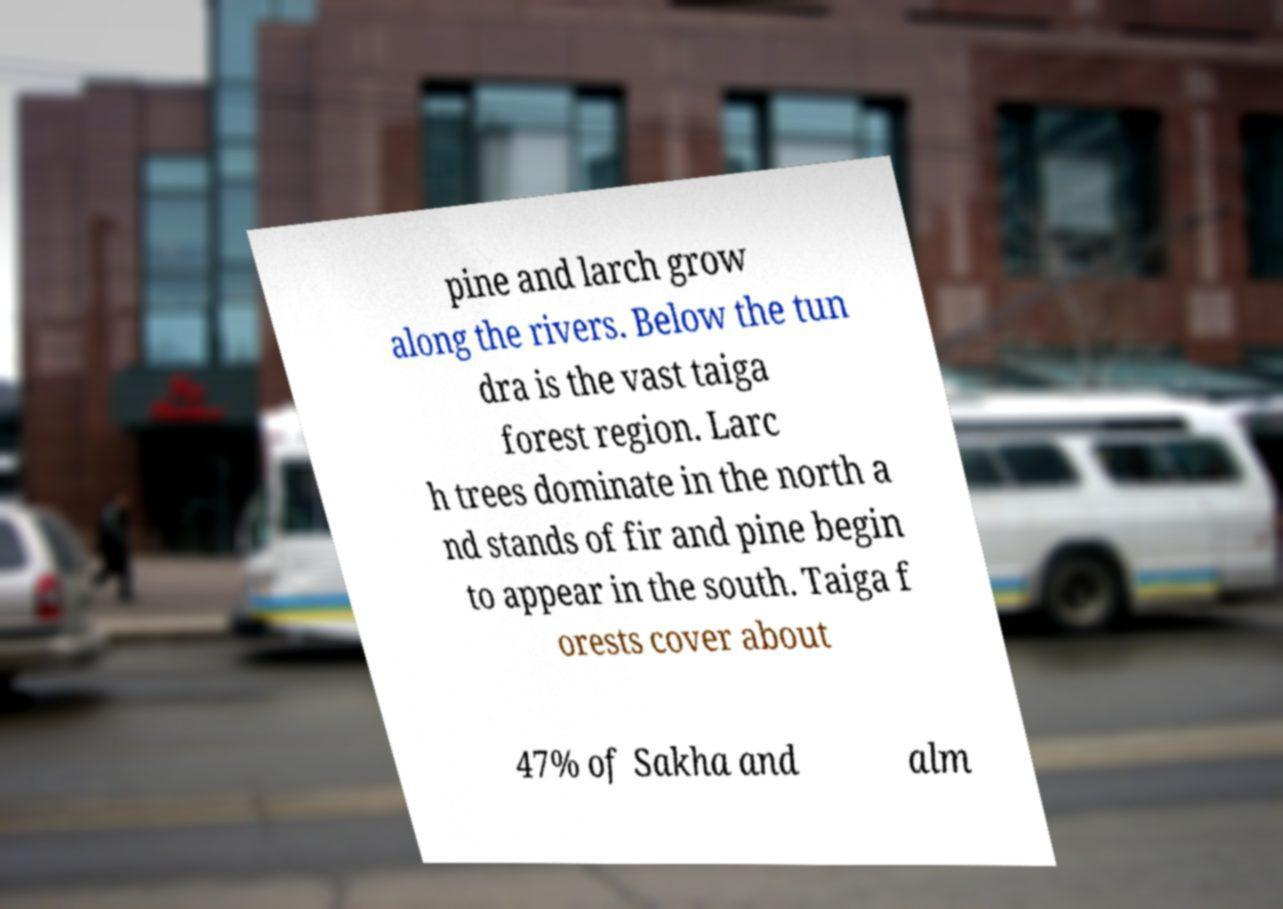What messages or text are displayed in this image? I need them in a readable, typed format. pine and larch grow along the rivers. Below the tun dra is the vast taiga forest region. Larc h trees dominate in the north a nd stands of fir and pine begin to appear in the south. Taiga f orests cover about 47% of Sakha and alm 